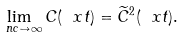Convert formula to latex. <formula><loc_0><loc_0><loc_500><loc_500>\lim _ { \ n c \to \infty } C ( \ x t ) = \widetilde { C } ^ { 2 } ( \ x t ) .</formula> 